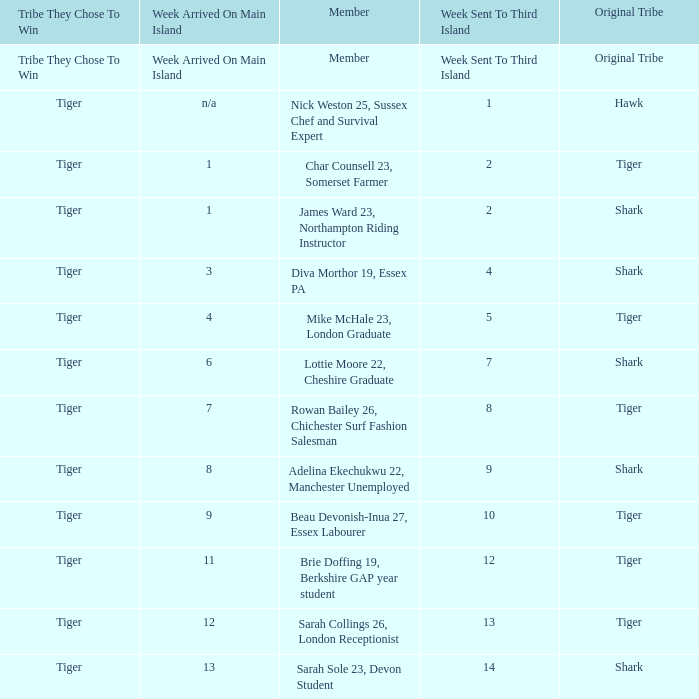What week was the member who arrived on the main island in week 6 sent to the third island? 7.0. 